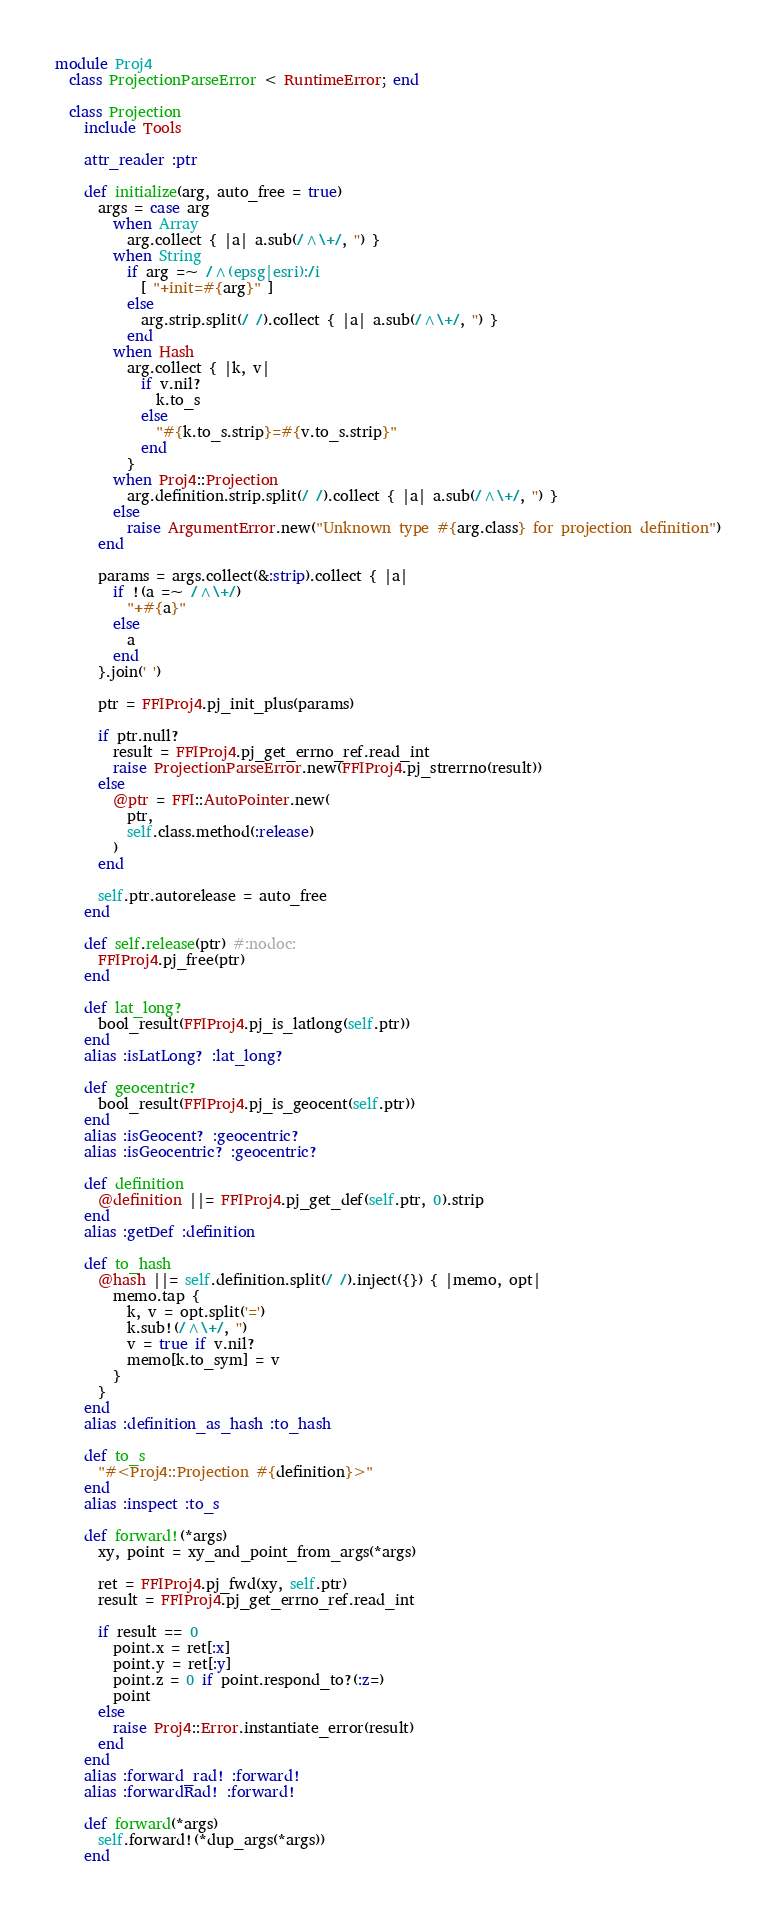<code> <loc_0><loc_0><loc_500><loc_500><_Ruby_>
module Proj4
  class ProjectionParseError < RuntimeError; end

  class Projection
    include Tools

    attr_reader :ptr

    def initialize(arg, auto_free = true)
      args = case arg
        when Array
          arg.collect { |a| a.sub(/^\+/, '') }
        when String
          if arg =~ /^(epsg|esri):/i
            [ "+init=#{arg}" ]
          else
            arg.strip.split(/ /).collect { |a| a.sub(/^\+/, '') }
          end
        when Hash
          arg.collect { |k, v|
            if v.nil?
              k.to_s
            else
              "#{k.to_s.strip}=#{v.to_s.strip}"
            end
          }
        when Proj4::Projection
          arg.definition.strip.split(/ /).collect { |a| a.sub(/^\+/, '') }
        else
          raise ArgumentError.new("Unknown type #{arg.class} for projection definition")
      end

      params = args.collect(&:strip).collect { |a|
        if !(a =~ /^\+/)
          "+#{a}"
        else
          a
        end
      }.join(' ')

      ptr = FFIProj4.pj_init_plus(params)

      if ptr.null?
        result = FFIProj4.pj_get_errno_ref.read_int
        raise ProjectionParseError.new(FFIProj4.pj_strerrno(result))
      else
        @ptr = FFI::AutoPointer.new(
          ptr,
          self.class.method(:release)
        )
      end

      self.ptr.autorelease = auto_free
    end

    def self.release(ptr) #:nodoc:
      FFIProj4.pj_free(ptr)
    end

    def lat_long?
      bool_result(FFIProj4.pj_is_latlong(self.ptr))
    end
    alias :isLatLong? :lat_long?

    def geocentric?
      bool_result(FFIProj4.pj_is_geocent(self.ptr))
    end
    alias :isGeocent? :geocentric?
    alias :isGeocentric? :geocentric?

    def definition
      @definition ||= FFIProj4.pj_get_def(self.ptr, 0).strip
    end
    alias :getDef :definition

    def to_hash
      @hash ||= self.definition.split(/ /).inject({}) { |memo, opt|
        memo.tap {
          k, v = opt.split('=')
          k.sub!(/^\+/, '')
          v = true if v.nil?
          memo[k.to_sym] = v
        }
      }
    end
    alias :definition_as_hash :to_hash

    def to_s
      "#<Proj4::Projection #{definition}>"
    end
    alias :inspect :to_s

    def forward!(*args)
      xy, point = xy_and_point_from_args(*args)

      ret = FFIProj4.pj_fwd(xy, self.ptr)
      result = FFIProj4.pj_get_errno_ref.read_int

      if result == 0
        point.x = ret[:x]
        point.y = ret[:y]
        point.z = 0 if point.respond_to?(:z=)
        point
      else
        raise Proj4::Error.instantiate_error(result)
      end
    end
    alias :forward_rad! :forward!
    alias :forwardRad! :forward!

    def forward(*args)
      self.forward!(*dup_args(*args))
    end</code> 